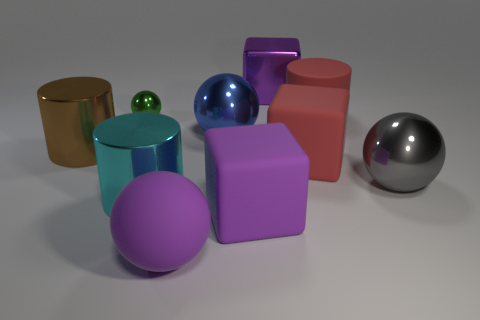Does the arrangement of these objects suggest any particular theme? The arrangement of objects in the image does not suggest a specific theme but rather seems to be a study in form and color. The various geometric shapes placed in close proximity could imply a focus on the aesthetics of three-dimensional forms and how they interact with light and space. 